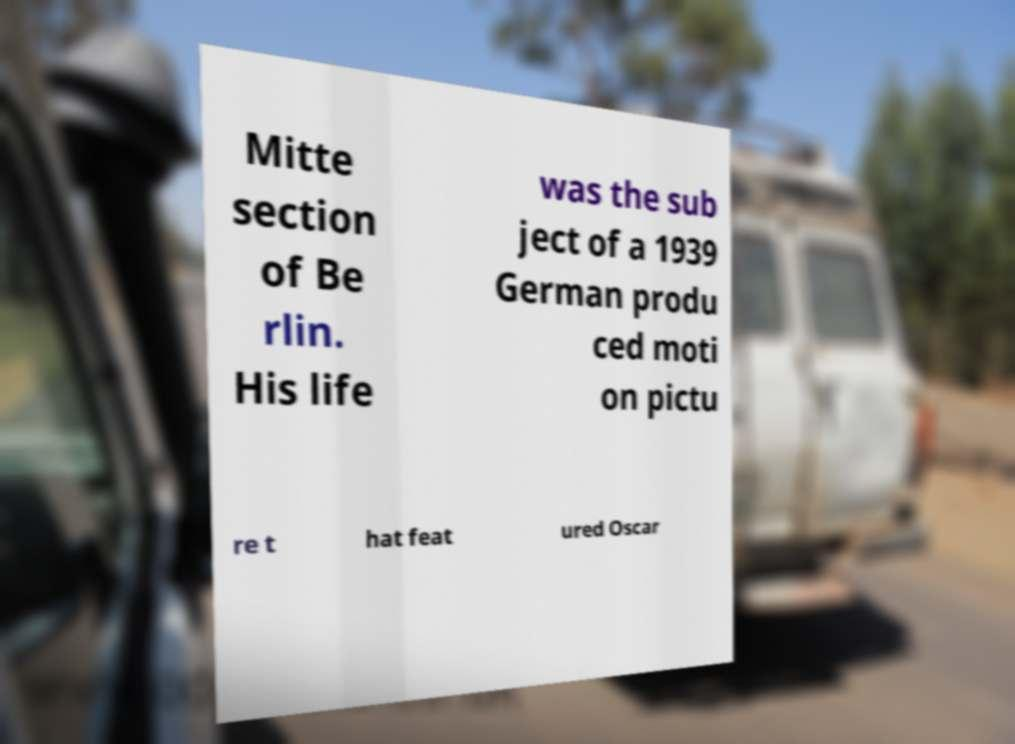Could you assist in decoding the text presented in this image and type it out clearly? Mitte section of Be rlin. His life was the sub ject of a 1939 German produ ced moti on pictu re t hat feat ured Oscar 